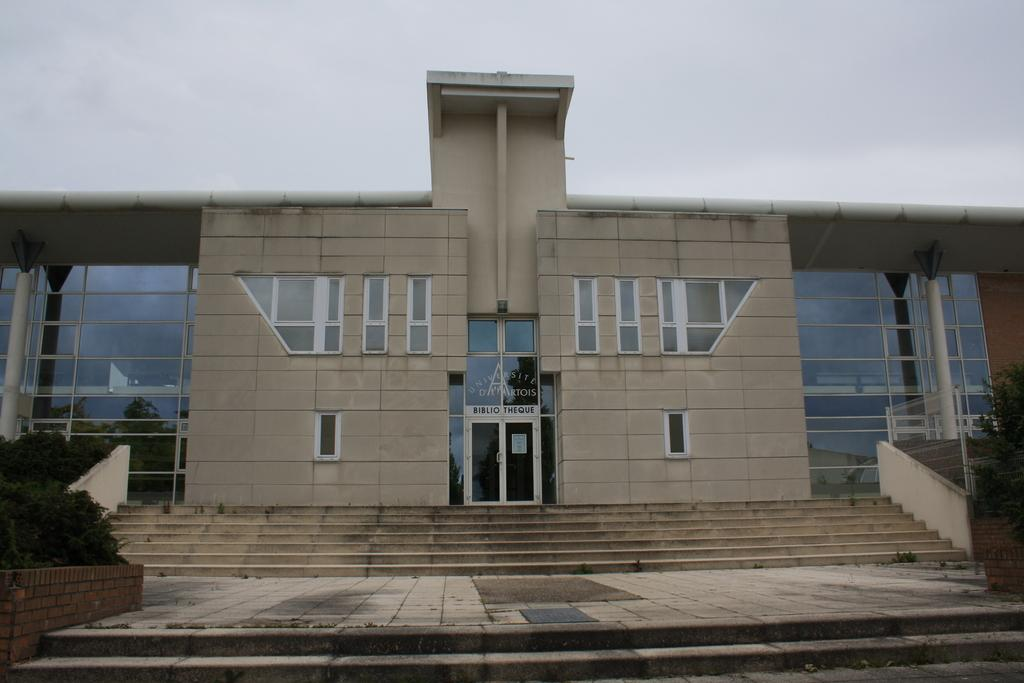What type of structure is present in the image? There is a building in the image. What features can be observed on the building? The building has windows, a door, and pillars. Are there any architectural elements in front of the building? Yes, there are stairs and trees in front of the building. What can be seen in the background of the image? The sky is visible in the background. What is the building's belief system, and how does it influence the design of the building? There is no information about the building's belief system in the image, so it cannot be determined how it might influence the design. 